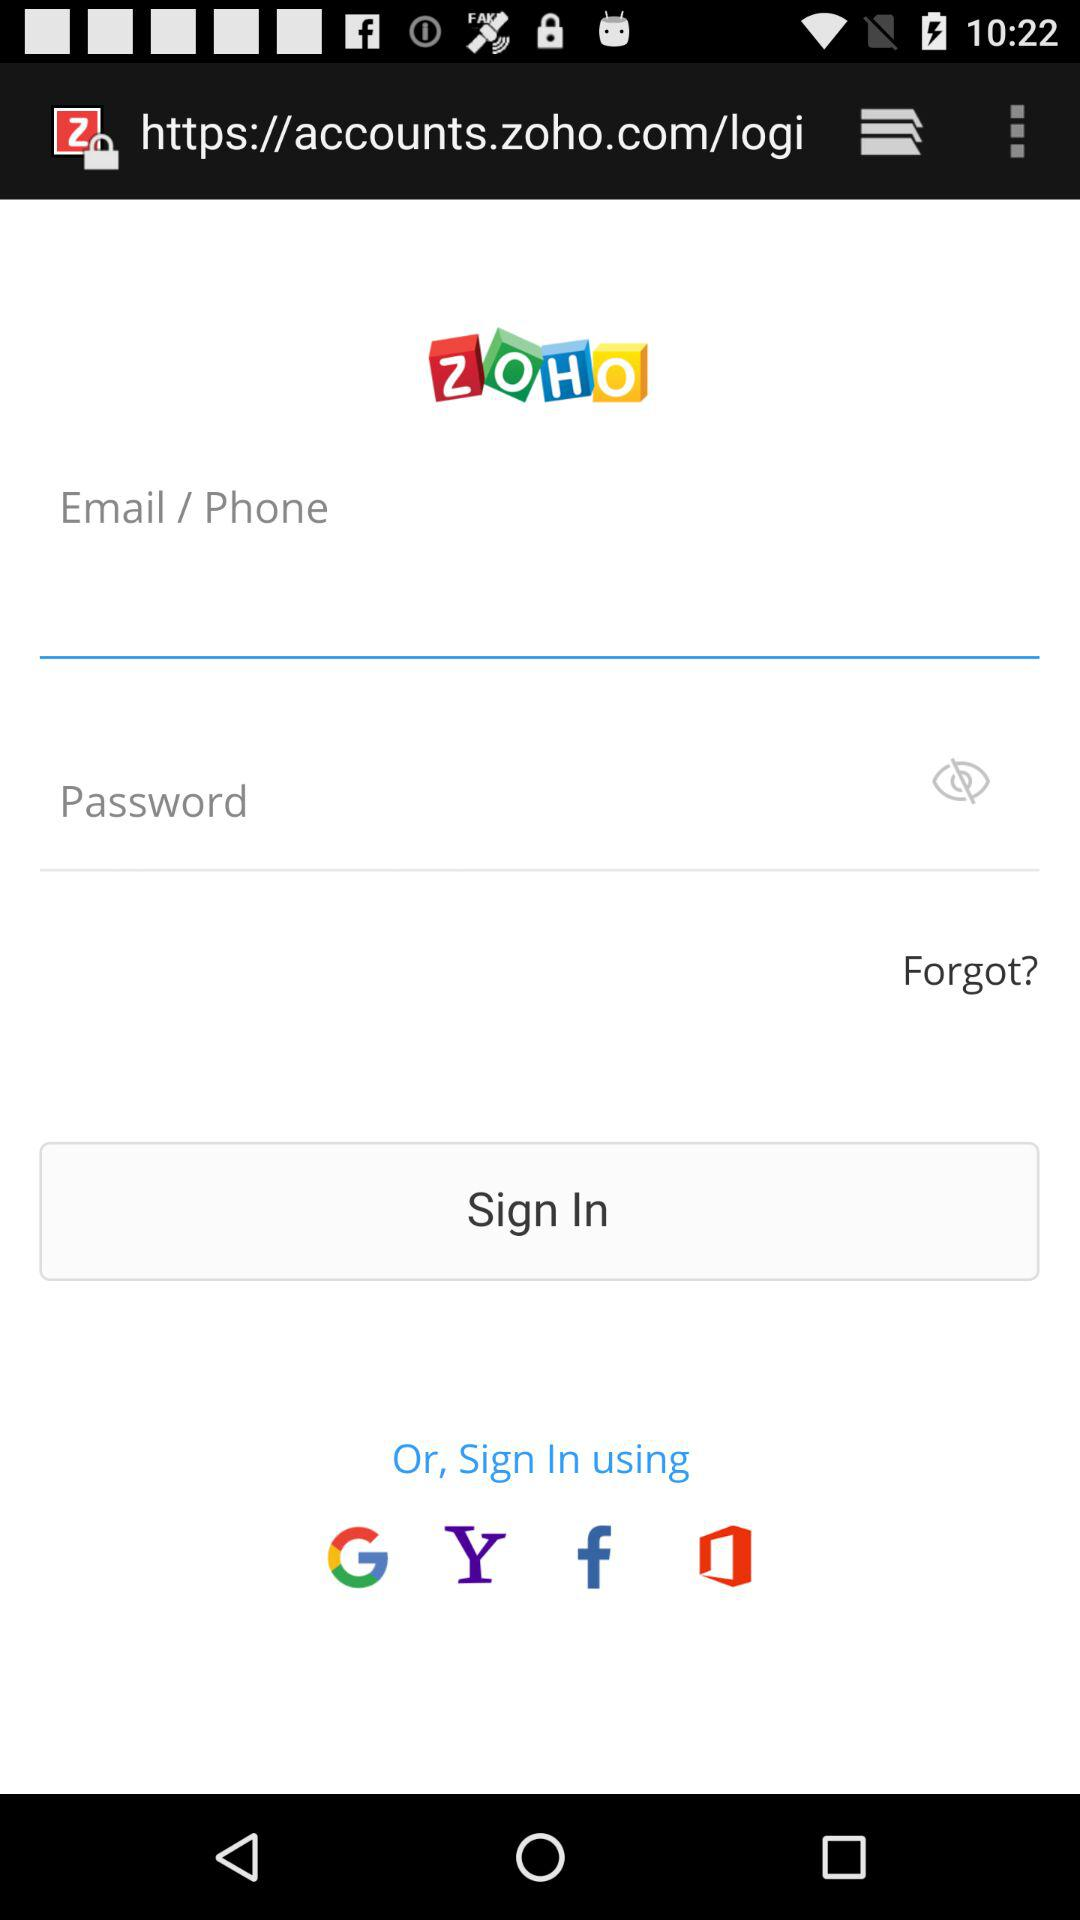How many inputs are there in the sign in form?
Answer the question using a single word or phrase. 2 